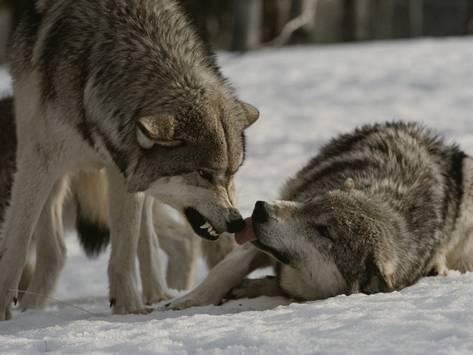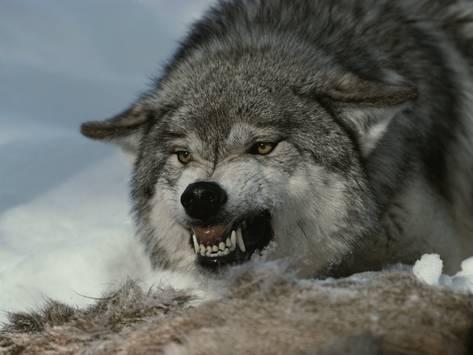The first image is the image on the left, the second image is the image on the right. Given the left and right images, does the statement "One image shows two wolves with one wolf on the ground and one standing, and the other image shows one wolf with all teeth bared and visible." hold true? Answer yes or no. Yes. The first image is the image on the left, the second image is the image on the right. For the images shown, is this caption "There is no more than one wolf in the right image." true? Answer yes or no. Yes. 